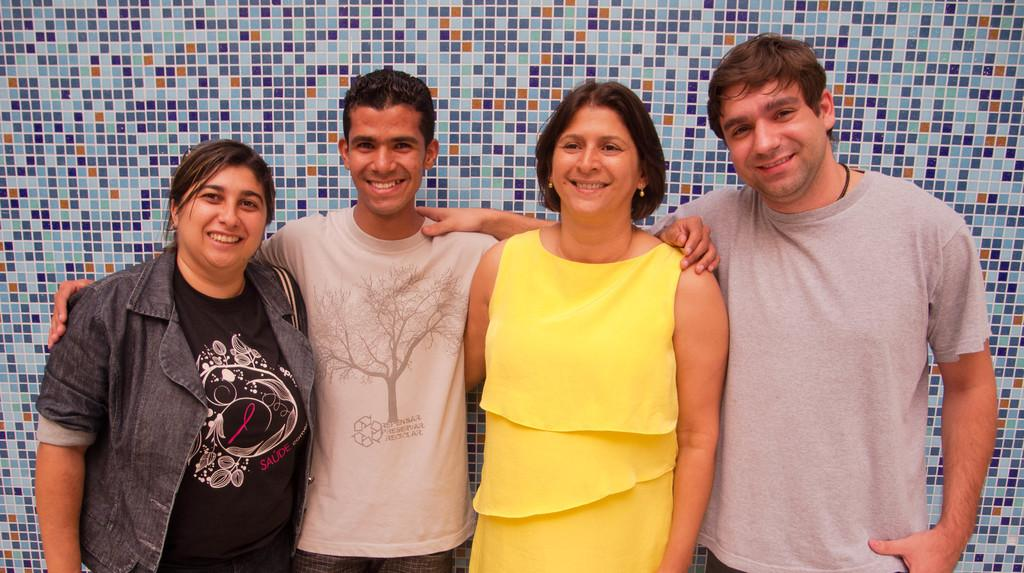How many people are present in the image? There are four people in the image. What expressions do the people have on their faces? The people are wearing smiles on their faces. What can be seen in the background of the image? There is a wall visible in the background of the image. What type of zinc object is being used by the people in the image? There is no zinc object present in the image; the people are simply smiling and there is a wall visible in the background. 